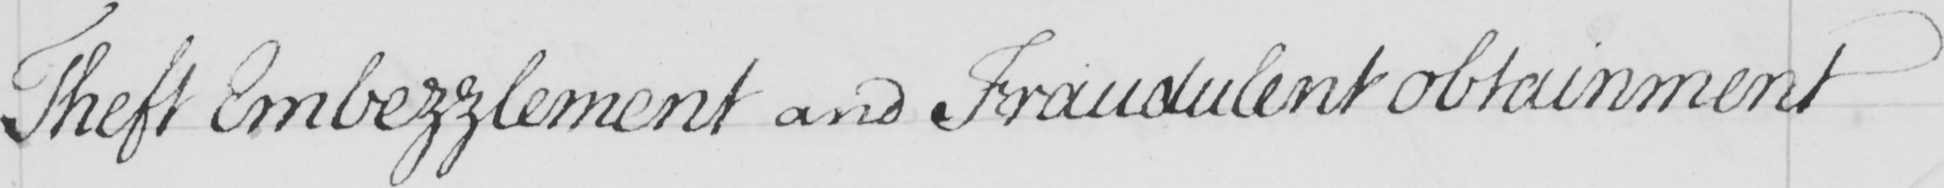What text is written in this handwritten line? Theft Embezzlement and Fraudulent obtainment 